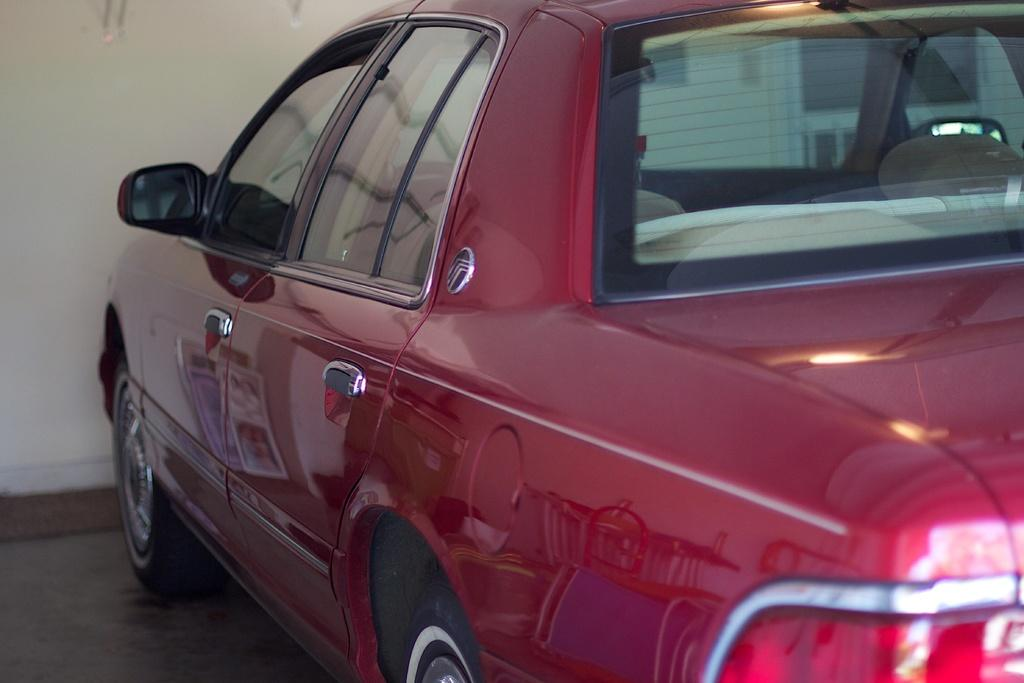What is the main subject of the image? The main subject of the image is a car. What color is the car? The car is red in color. What can be seen in the background of the image? There is a wall in the background of the image. Can you see a gun being used in the image? No, there is no gun present in the image. What type of oven is visible in the image? There is no oven present in the image. 